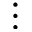Convert formula to latex. <formula><loc_0><loc_0><loc_500><loc_500>\vdots</formula> 